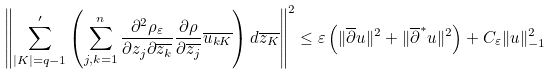<formula> <loc_0><loc_0><loc_500><loc_500>\left \| \sum ^ { \prime } _ { | K | = q - 1 } \left ( \sum _ { j , k = 1 } ^ { n } \frac { \partial ^ { 2 } \rho _ { \varepsilon } } { \partial z _ { j } \partial \overline { z _ { k } } } \frac { \partial \rho } { \partial \overline { z _ { j } } } \overline { u _ { k K } } \right ) d \overline { z _ { K } } \right \| ^ { 2 } \leq \varepsilon \left ( \| \overline { \partial } u \| ^ { 2 } + \| \overline { \partial } ^ { * } u \| ^ { 2 } \right ) + C _ { \varepsilon } \| u \| _ { - 1 } ^ { 2 }</formula> 